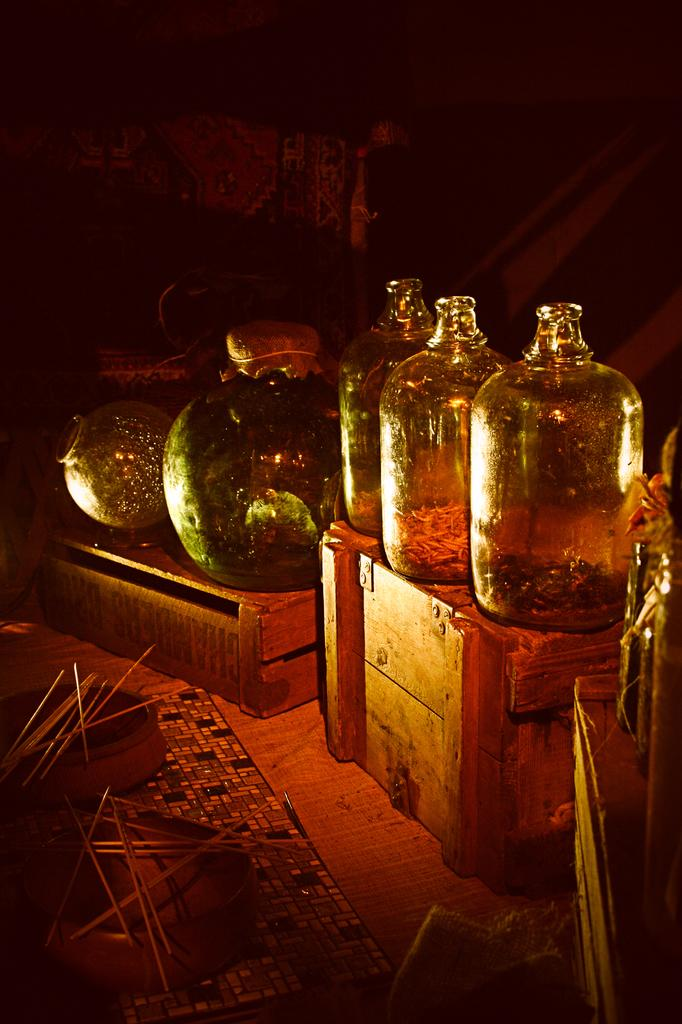How many bottles can be seen in the image? There are three bottles in the image. What are the bottles referred to as in the image? The bottles are described as pots. What other objects are present in the image besides the bottles? There are bowls and chopsticks visible in the image. What surface is visible in the image? The floor is visible in the image. What type of stocking is hanging from the ceiling in the image? There is no stocking hanging from the ceiling in the image. What sound can be heard coming from the bottles in the image? There is no sound coming from the bottles in the image, as they are stationary objects. 